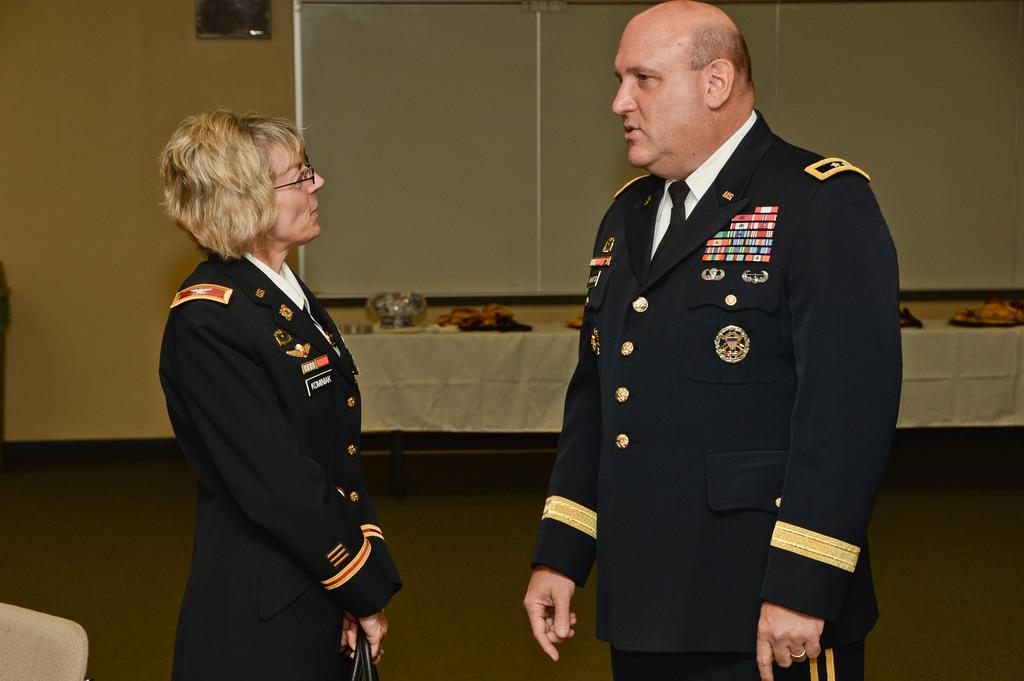Who are the people in the image? There is a man and a woman in the image. Where are the man and woman located in the image? The man and woman are in the center of the image. What can be seen in the background of the image? There is a table in the background of the image. How many seats are available for the man and woman in the image? There is no information about seats in the image; it only shows the man and woman standing in the center. What boundary is present in the image? There is no boundary mentioned or visible in the image. 